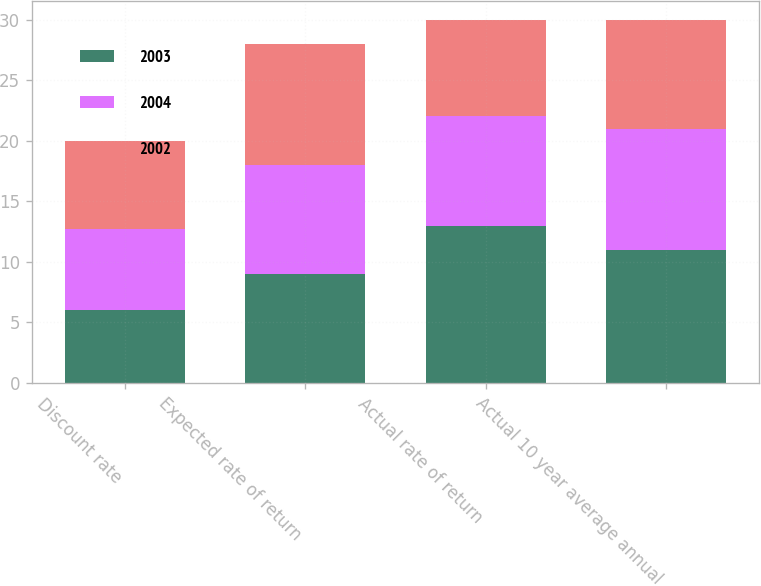<chart> <loc_0><loc_0><loc_500><loc_500><stacked_bar_chart><ecel><fcel>Discount rate<fcel>Expected rate of return<fcel>Actual rate of return<fcel>Actual 10 year average annual<nl><fcel>2003<fcel>6<fcel>9<fcel>13<fcel>11<nl><fcel>2004<fcel>6.75<fcel>9<fcel>9<fcel>10<nl><fcel>2002<fcel>7.25<fcel>10<fcel>8<fcel>9<nl></chart> 